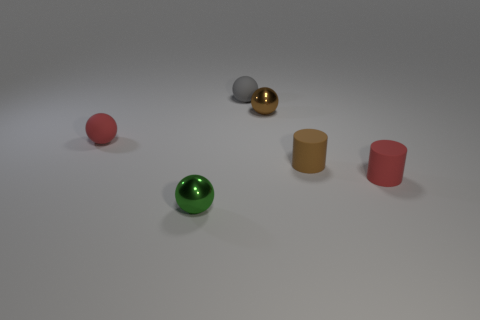Subtract all small green balls. How many balls are left? 3 Add 3 brown shiny balls. How many objects exist? 9 Subtract all red cylinders. How many cylinders are left? 1 Subtract all balls. How many objects are left? 2 Subtract 1 spheres. How many spheres are left? 3 Add 5 cylinders. How many cylinders exist? 7 Subtract 1 brown cylinders. How many objects are left? 5 Subtract all yellow balls. Subtract all gray cylinders. How many balls are left? 4 Subtract all gray balls. How many red cylinders are left? 1 Subtract all large cyan cylinders. Subtract all tiny gray objects. How many objects are left? 5 